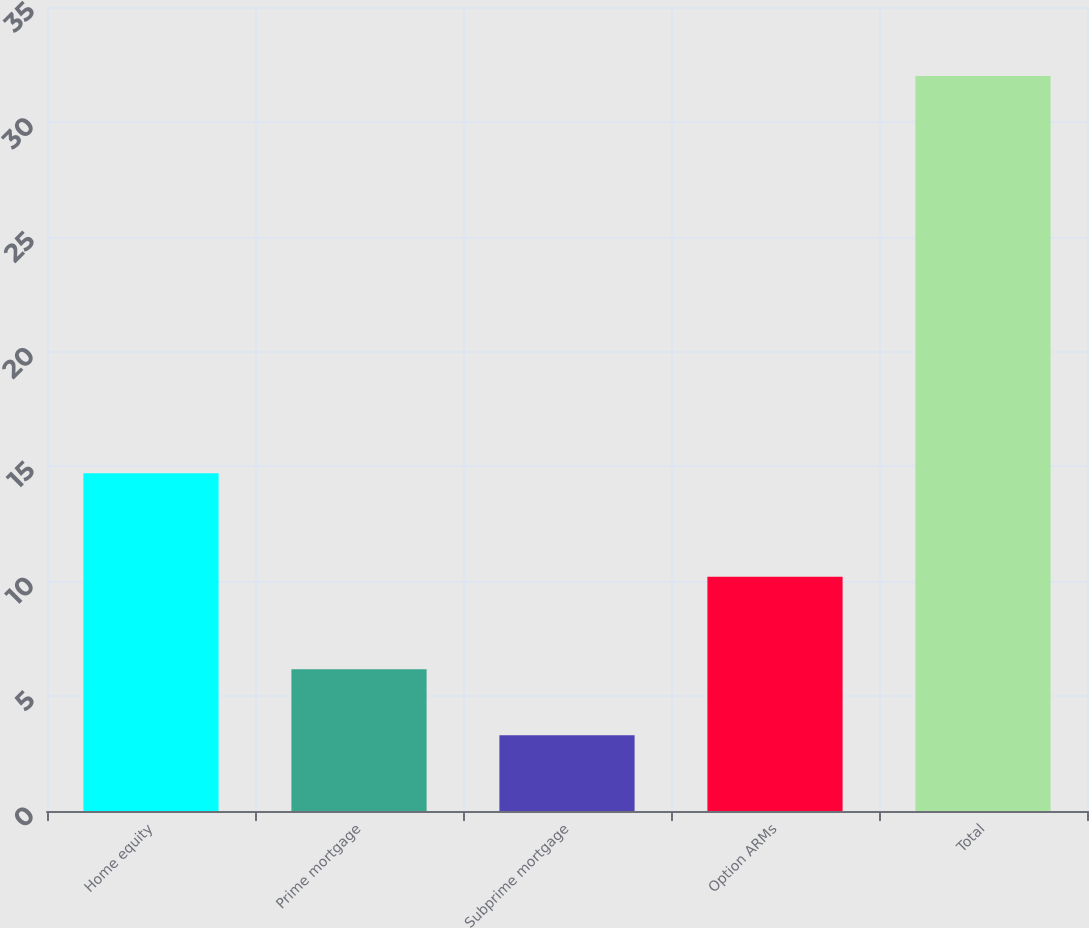Convert chart. <chart><loc_0><loc_0><loc_500><loc_500><bar_chart><fcel>Home equity<fcel>Prime mortgage<fcel>Subprime mortgage<fcel>Option ARMs<fcel>Total<nl><fcel>14.7<fcel>6.17<fcel>3.3<fcel>10.2<fcel>32<nl></chart> 